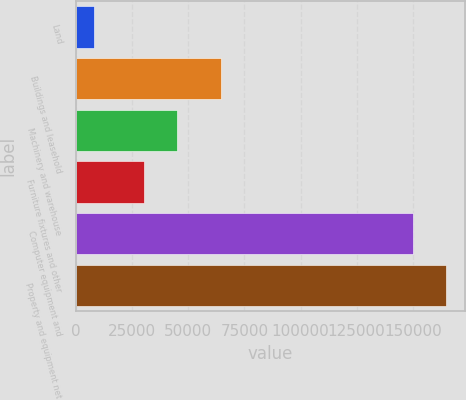Convert chart. <chart><loc_0><loc_0><loc_500><loc_500><bar_chart><fcel>Land<fcel>Buildings and leasehold<fcel>Machinery and warehouse<fcel>Furniture fixtures and other<fcel>Computer equipment and<fcel>Property and equipment net<nl><fcel>7754<fcel>64410<fcel>44821.1<fcel>30176<fcel>150193<fcel>164838<nl></chart> 